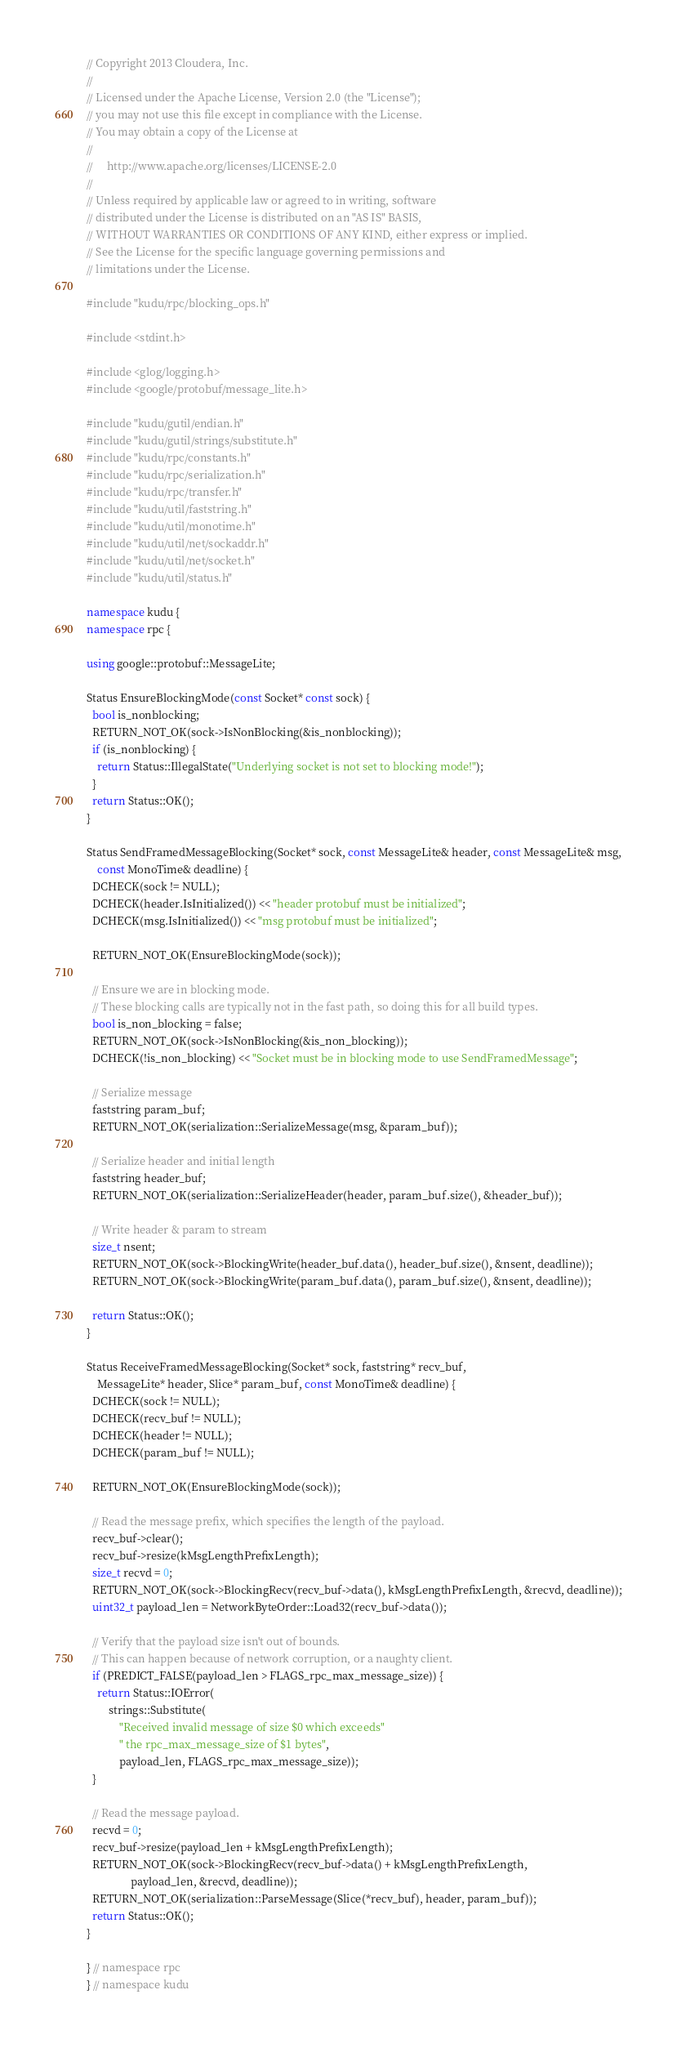<code> <loc_0><loc_0><loc_500><loc_500><_C++_>// Copyright 2013 Cloudera, Inc.
//
// Licensed under the Apache License, Version 2.0 (the "License");
// you may not use this file except in compliance with the License.
// You may obtain a copy of the License at
//
//     http://www.apache.org/licenses/LICENSE-2.0
//
// Unless required by applicable law or agreed to in writing, software
// distributed under the License is distributed on an "AS IS" BASIS,
// WITHOUT WARRANTIES OR CONDITIONS OF ANY KIND, either express or implied.
// See the License for the specific language governing permissions and
// limitations under the License.

#include "kudu/rpc/blocking_ops.h"

#include <stdint.h>

#include <glog/logging.h>
#include <google/protobuf/message_lite.h>

#include "kudu/gutil/endian.h"
#include "kudu/gutil/strings/substitute.h"
#include "kudu/rpc/constants.h"
#include "kudu/rpc/serialization.h"
#include "kudu/rpc/transfer.h"
#include "kudu/util/faststring.h"
#include "kudu/util/monotime.h"
#include "kudu/util/net/sockaddr.h"
#include "kudu/util/net/socket.h"
#include "kudu/util/status.h"

namespace kudu {
namespace rpc {

using google::protobuf::MessageLite;

Status EnsureBlockingMode(const Socket* const sock) {
  bool is_nonblocking;
  RETURN_NOT_OK(sock->IsNonBlocking(&is_nonblocking));
  if (is_nonblocking) {
    return Status::IllegalState("Underlying socket is not set to blocking mode!");
  }
  return Status::OK();
}

Status SendFramedMessageBlocking(Socket* sock, const MessageLite& header, const MessageLite& msg,
    const MonoTime& deadline) {
  DCHECK(sock != NULL);
  DCHECK(header.IsInitialized()) << "header protobuf must be initialized";
  DCHECK(msg.IsInitialized()) << "msg protobuf must be initialized";

  RETURN_NOT_OK(EnsureBlockingMode(sock));

  // Ensure we are in blocking mode.
  // These blocking calls are typically not in the fast path, so doing this for all build types.
  bool is_non_blocking = false;
  RETURN_NOT_OK(sock->IsNonBlocking(&is_non_blocking));
  DCHECK(!is_non_blocking) << "Socket must be in blocking mode to use SendFramedMessage";

  // Serialize message
  faststring param_buf;
  RETURN_NOT_OK(serialization::SerializeMessage(msg, &param_buf));

  // Serialize header and initial length
  faststring header_buf;
  RETURN_NOT_OK(serialization::SerializeHeader(header, param_buf.size(), &header_buf));

  // Write header & param to stream
  size_t nsent;
  RETURN_NOT_OK(sock->BlockingWrite(header_buf.data(), header_buf.size(), &nsent, deadline));
  RETURN_NOT_OK(sock->BlockingWrite(param_buf.data(), param_buf.size(), &nsent, deadline));

  return Status::OK();
}

Status ReceiveFramedMessageBlocking(Socket* sock, faststring* recv_buf,
    MessageLite* header, Slice* param_buf, const MonoTime& deadline) {
  DCHECK(sock != NULL);
  DCHECK(recv_buf != NULL);
  DCHECK(header != NULL);
  DCHECK(param_buf != NULL);

  RETURN_NOT_OK(EnsureBlockingMode(sock));

  // Read the message prefix, which specifies the length of the payload.
  recv_buf->clear();
  recv_buf->resize(kMsgLengthPrefixLength);
  size_t recvd = 0;
  RETURN_NOT_OK(sock->BlockingRecv(recv_buf->data(), kMsgLengthPrefixLength, &recvd, deadline));
  uint32_t payload_len = NetworkByteOrder::Load32(recv_buf->data());

  // Verify that the payload size isn't out of bounds.
  // This can happen because of network corruption, or a naughty client.
  if (PREDICT_FALSE(payload_len > FLAGS_rpc_max_message_size)) {
    return Status::IOError(
        strings::Substitute(
            "Received invalid message of size $0 which exceeds"
            " the rpc_max_message_size of $1 bytes",
            payload_len, FLAGS_rpc_max_message_size));
  }

  // Read the message payload.
  recvd = 0;
  recv_buf->resize(payload_len + kMsgLengthPrefixLength);
  RETURN_NOT_OK(sock->BlockingRecv(recv_buf->data() + kMsgLengthPrefixLength,
                payload_len, &recvd, deadline));
  RETURN_NOT_OK(serialization::ParseMessage(Slice(*recv_buf), header, param_buf));
  return Status::OK();
}

} // namespace rpc
} // namespace kudu
</code> 